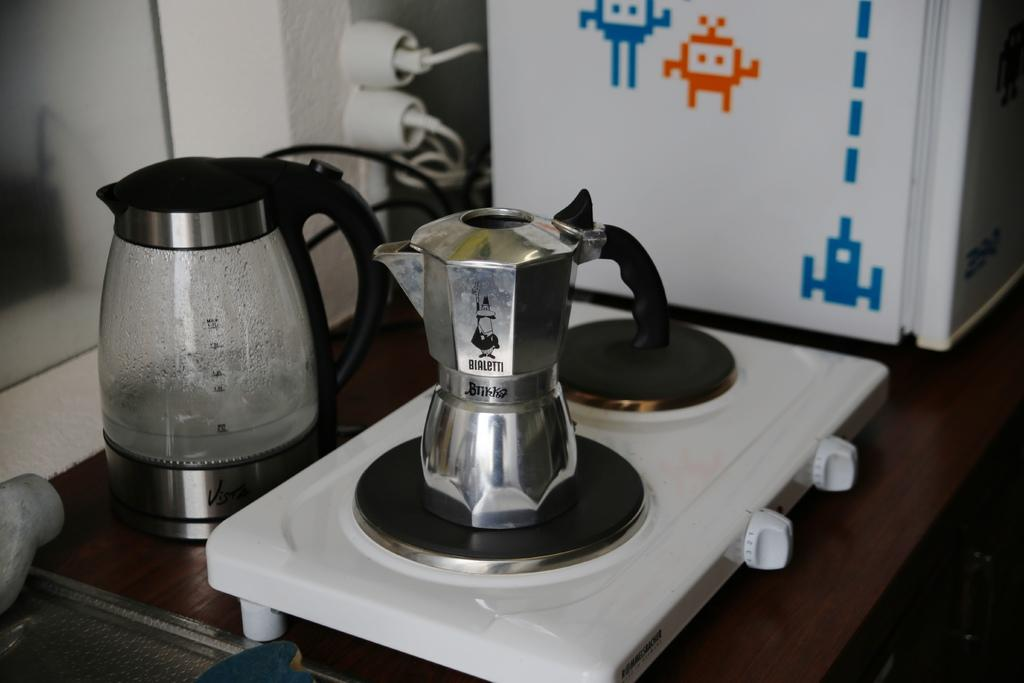<image>
Create a compact narrative representing the image presented. A pot to make espresso, made by bialetti, sits on a burner. 